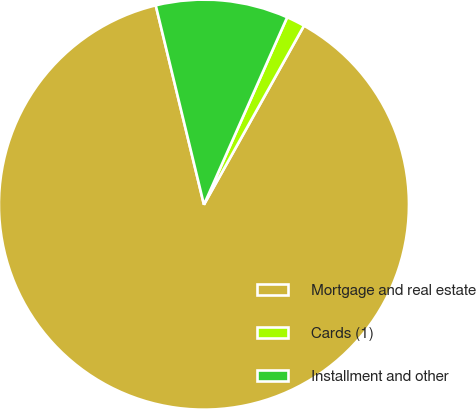Convert chart. <chart><loc_0><loc_0><loc_500><loc_500><pie_chart><fcel>Mortgage and real estate<fcel>Cards (1)<fcel>Installment and other<nl><fcel>88.11%<fcel>1.46%<fcel>10.43%<nl></chart> 